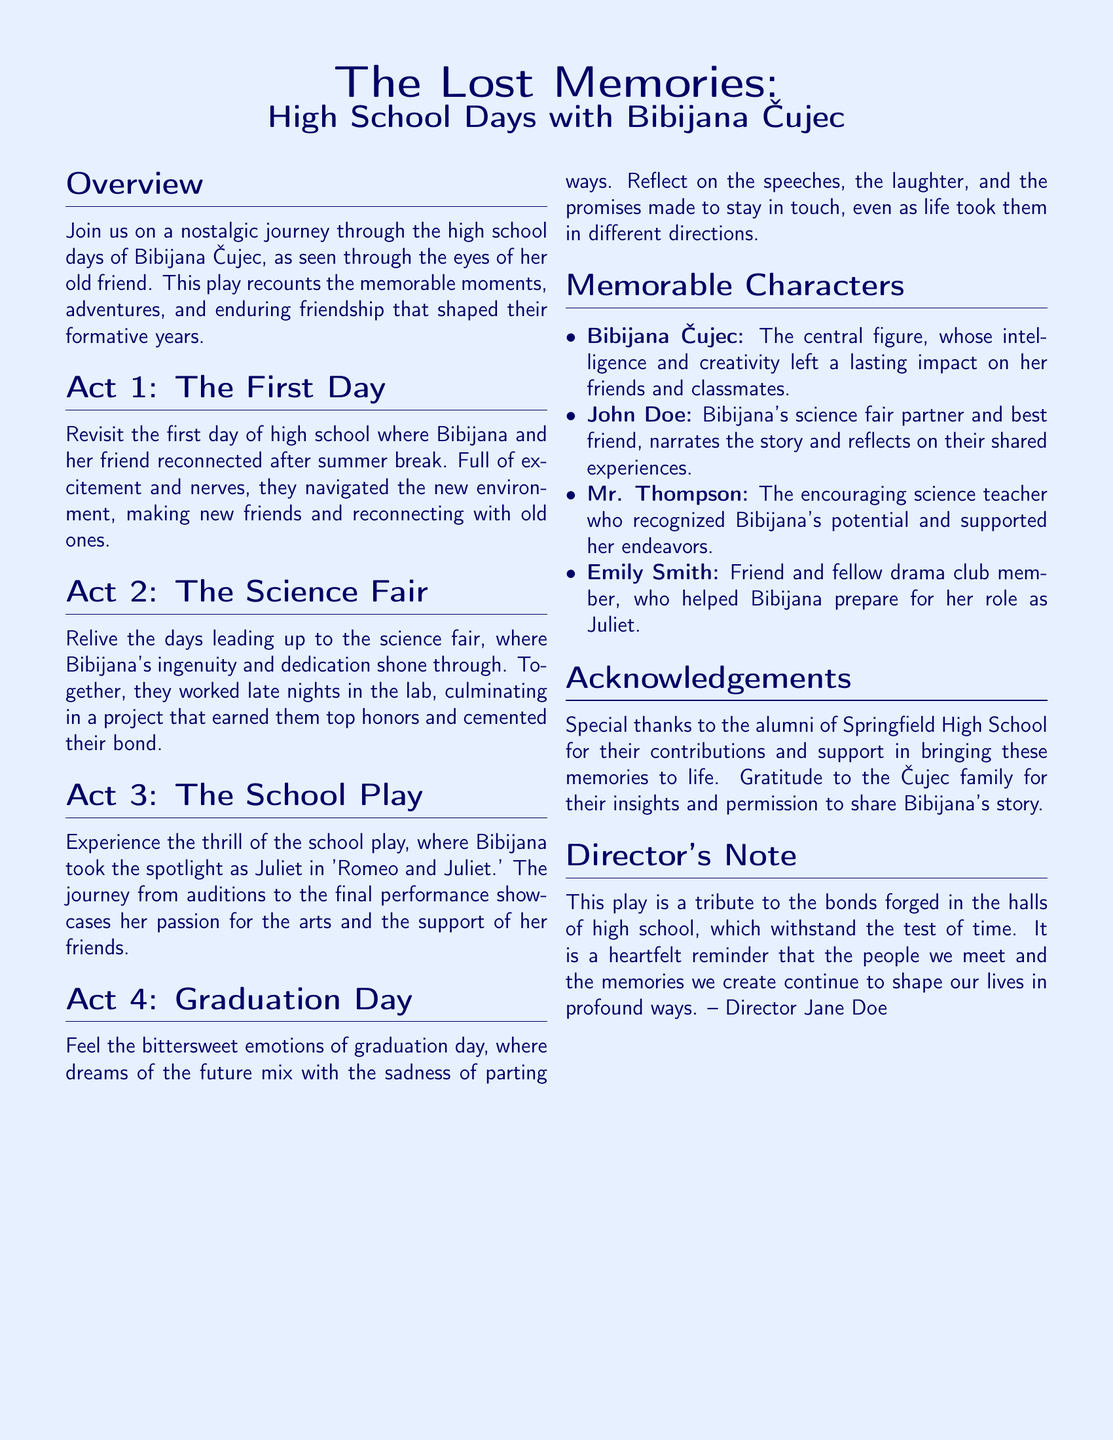What is the title of the play? The title is given at the beginning of the document, highlighting its theme and subject.
Answer: The Lost Memories: High School Days with Bibijana Čujec Who narrates the story? The document specifies the central character who tells the story of their high school days with Bibijana.
Answer: John Doe What role did Bibijana play in the school play? The document explicitly mentions her role in the school play as part of the overview of the acts.
Answer: Juliet Which act covers the science fair? The acts are numbered in the document, detailing the events described in each one.
Answer: Act 2 What is the primary feature of the director's note? The note summarizes the intention behind the play and how it connects to high school memories.
Answer: Tribute to the bonds Who is recognized as the encouraging science teacher? The document lists characters and highlights specific individuals and their relationships with Bibijana.
Answer: Mr. Thompson How many acts are in the play? The structure of the play is outlined in the document with clearly defined acts.
Answer: Four What emotion is associated with graduation day? The document describes the feelings tied to graduation day, showing the complexity of the moment.
Answer: Bittersweet What is the setting of the play? The overview introduces the primary historical context for the events and the content.
Answer: High school days 